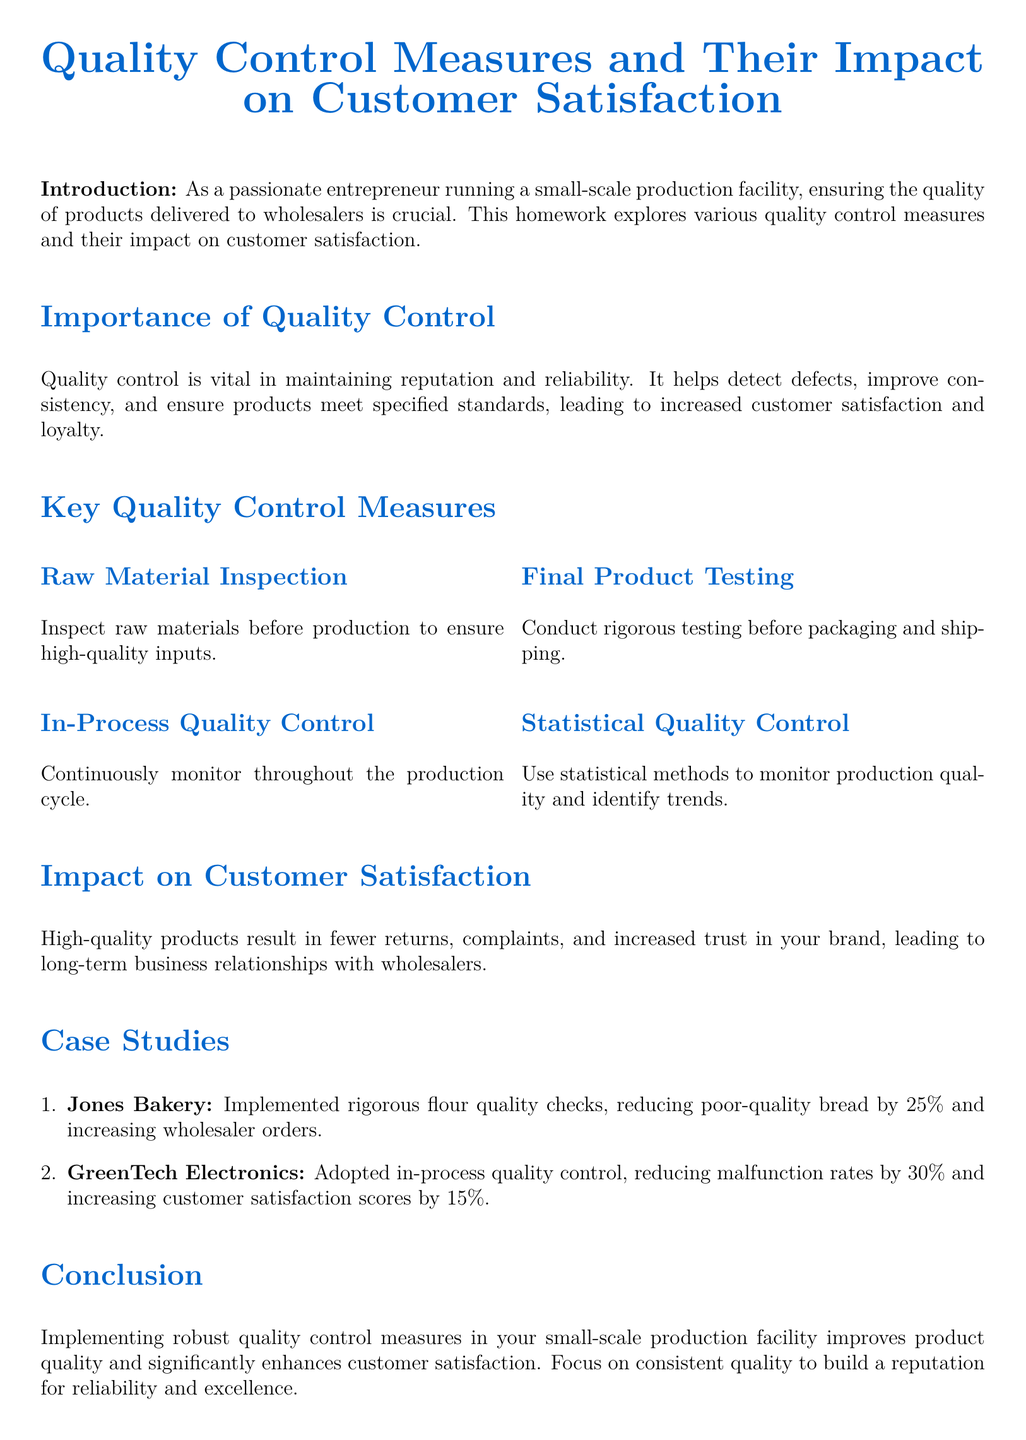what is the main focus of the document? The document discusses quality control measures and their impact on customer satisfaction in a production facility.
Answer: quality control measures and their impact on customer satisfaction what are the two key types of quality control measures mentioned? The document lists various measures, but specifically highlights raw material inspection and in-process quality control.
Answer: raw material inspection and in-process quality control how much did Jones Bakery reduce poor-quality bread by after implementing quality checks? The specific percentage reduction in poor-quality bread is provided as a notable outcome for Jones Bakery.
Answer: 25% what statistical method is used to monitor production quality? The document mentions a specific approach that utilizes statistical methods to oversee production quality.
Answer: Statistical Quality Control what improved customer satisfaction scores at GreenTech Electronics by 15%? The document identifies a specific quality measure that led to an increase in customer satisfaction scores for GreenTech Electronics.
Answer: in-process quality control how many case studies are included in the document? The document lists a total of two case studies that illustrate the benefits of quality control measures.
Answer: 2 what is the primary benefit of high-quality products according to the document? The document indicates a general benefit that results from maintaining high product quality in the context of customer relations.
Answer: fewer returns and complaints which reference focuses on statistical quality control? The document cites a specific reference that relates to the topic of statistical quality control.
Answer: Montgomery, D.C. (2012). Introduction to Statistical Quality Control what is the intended outcome of implementing robust quality control measures? The document concludes with a clear statement about the desired effect of adopting quality measures within a production facility.
Answer: improve product quality and enhance customer satisfaction 